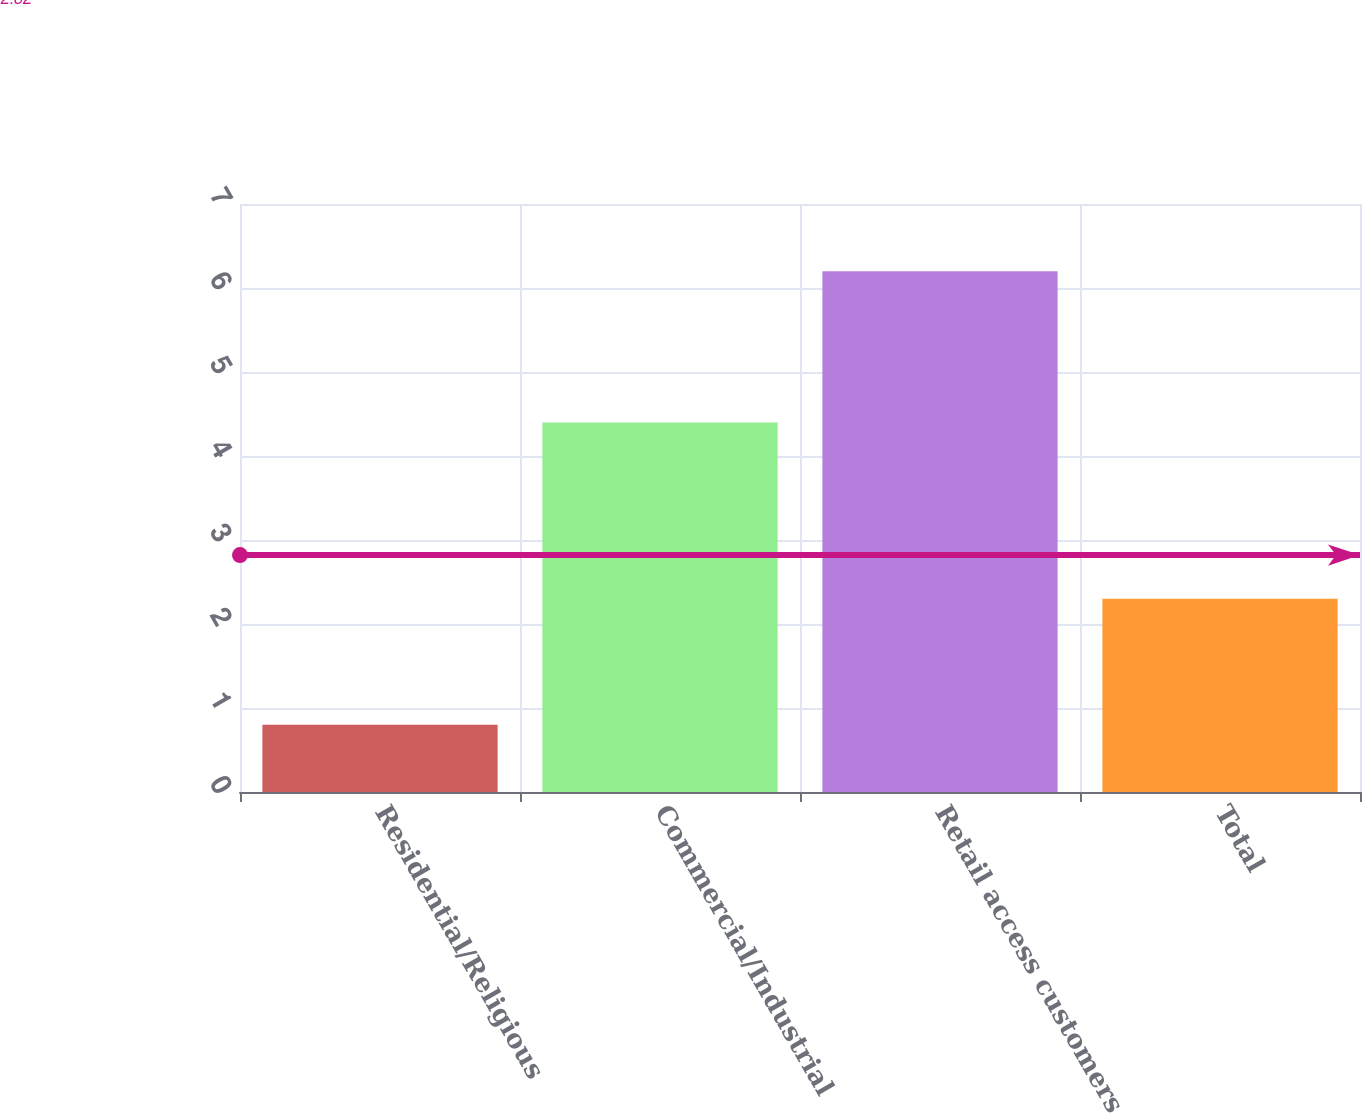Convert chart. <chart><loc_0><loc_0><loc_500><loc_500><bar_chart><fcel>Residential/Religious<fcel>Commercial/Industrial<fcel>Retail access customers<fcel>Total<nl><fcel>0.8<fcel>4.4<fcel>6.2<fcel>2.3<nl></chart> 